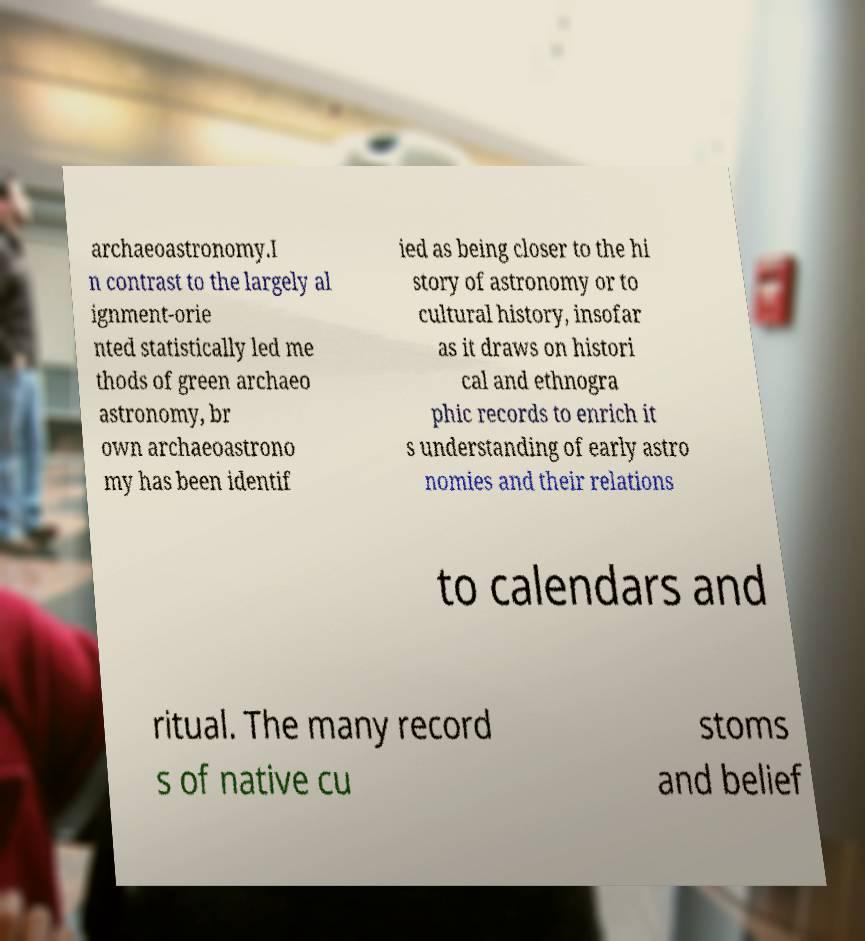Could you extract and type out the text from this image? archaeoastronomy.I n contrast to the largely al ignment-orie nted statistically led me thods of green archaeo astronomy, br own archaeoastrono my has been identif ied as being closer to the hi story of astronomy or to cultural history, insofar as it draws on histori cal and ethnogra phic records to enrich it s understanding of early astro nomies and their relations to calendars and ritual. The many record s of native cu stoms and belief 